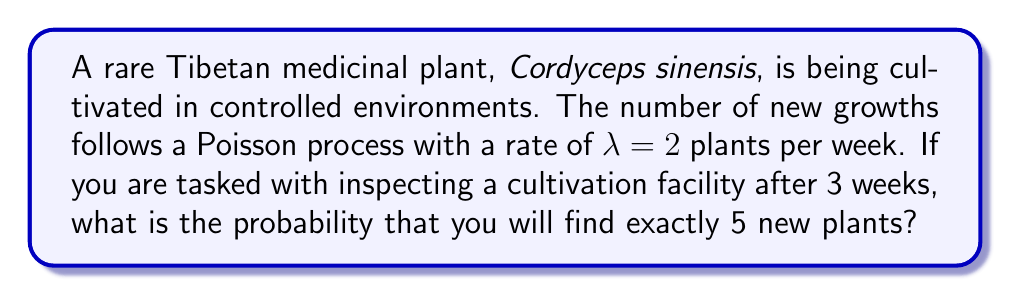Show me your answer to this math problem. To solve this problem, we'll use the Poisson distribution formula:

$$ P(X = k) = \frac{e^{-\lambda t}(\lambda t)^k}{k!} $$

Where:
- $\lambda$ is the rate parameter (2 plants per week)
- $t$ is the time period (3 weeks)
- $k$ is the number of events we're interested in (5 plants)

Steps:
1) Calculate $\lambda t$:
   $\lambda t = 2 \times 3 = 6$

2) Substitute values into the Poisson formula:
   $$ P(X = 5) = \frac{e^{-6}(6)^5}{5!} $$

3) Calculate $e^{-6}$:
   $e^{-6} \approx 0.00247875$

4) Calculate $6^5$:
   $6^5 = 7776$

5) Calculate $5!$:
   $5! = 5 \times 4 \times 3 \times 2 \times 1 = 120$

6) Put it all together:
   $$ P(X = 5) = \frac{0.00247875 \times 7776}{120} \approx 0.16062 $$

7) Convert to a percentage:
   $0.16062 \times 100\% = 16.062\%$
Answer: 16.062% 